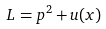Convert formula to latex. <formula><loc_0><loc_0><loc_500><loc_500>L = p ^ { 2 } + u ( x )</formula> 